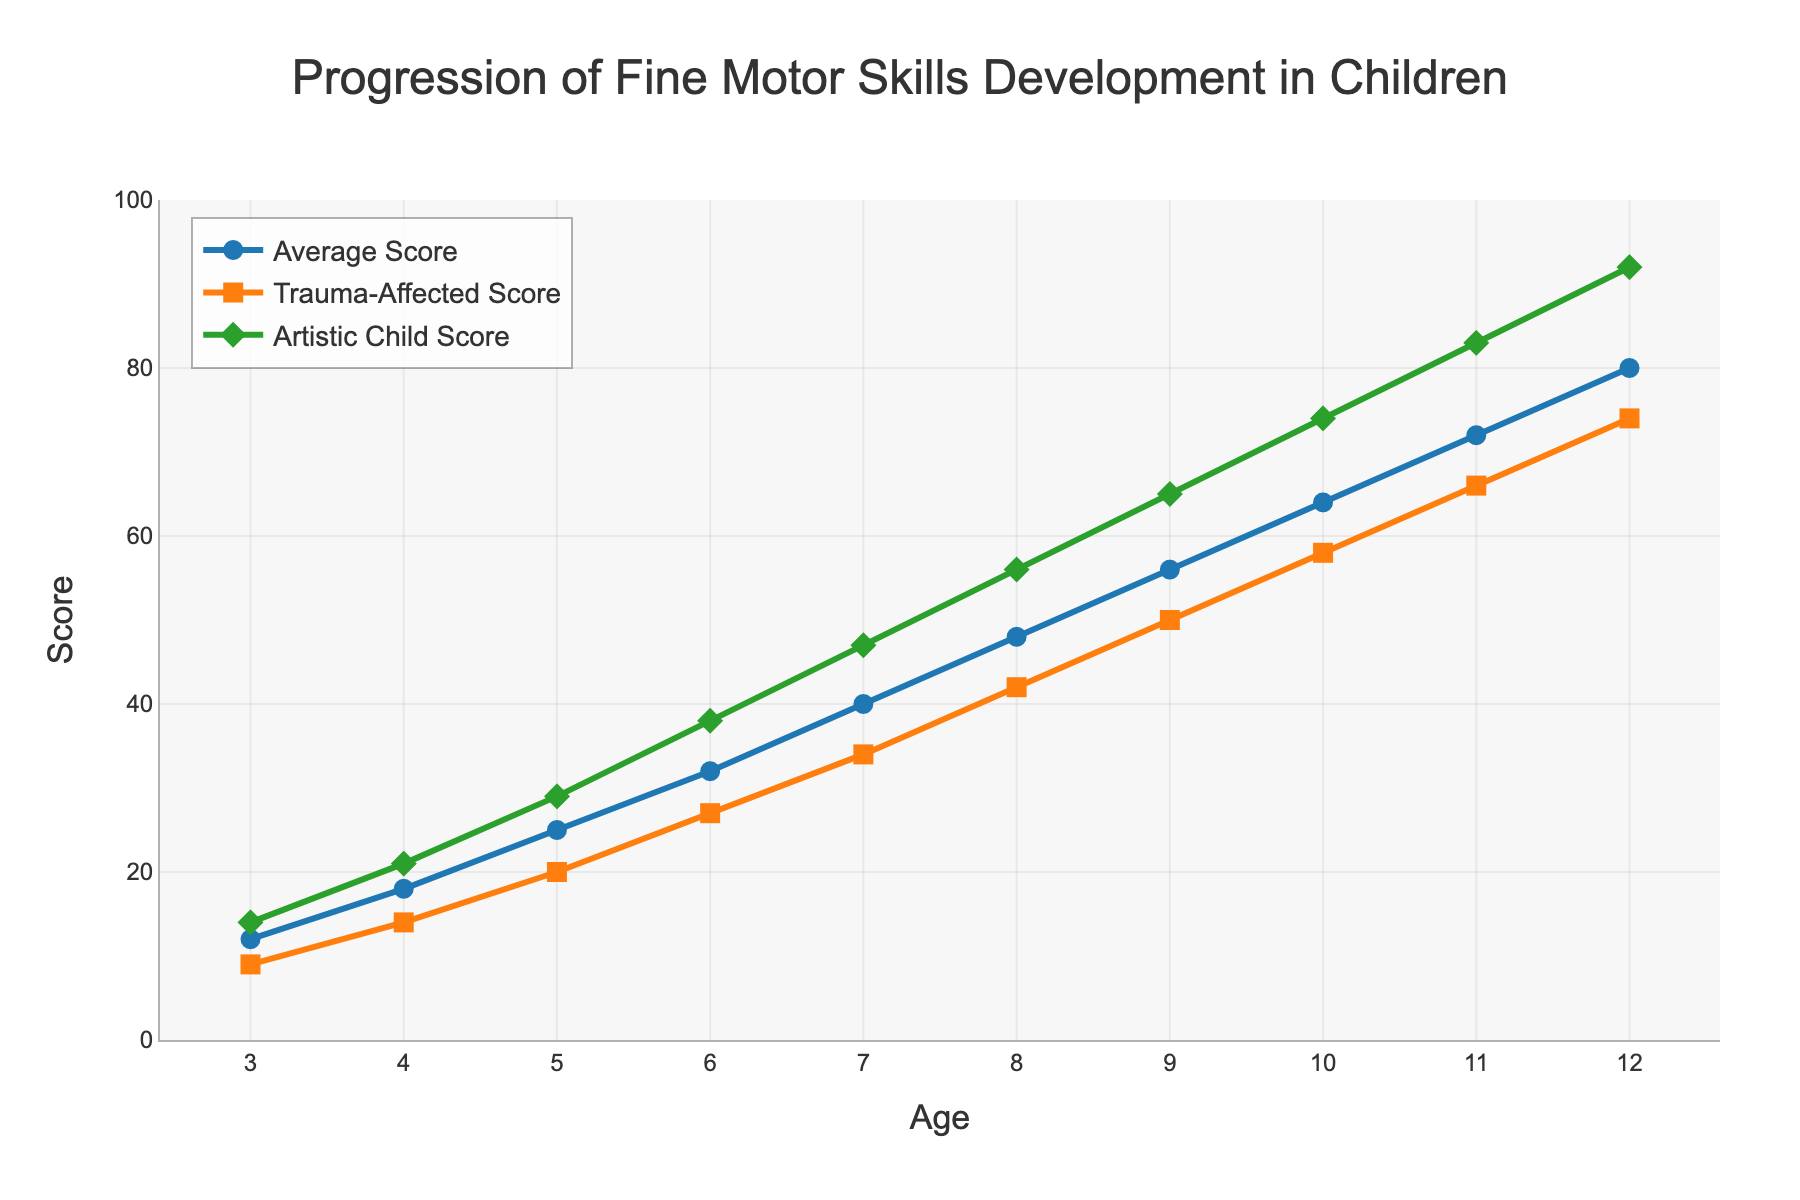What is the score difference between an average child and a trauma-affected child at age 6? Look at the score for the Average Score line and the Trauma-Affected Score line at age 6. The Average Score is 32, and the Trauma-Affected Score is 27. The difference is 32 - 27.
Answer: 5 Between which ages does the Artistic Child Score exhibit the steepest increase? Observe the slope of the Artistic Child Score line. The steepest increase is when the line ascends most sharply. From age 5 to 6, the score jumps from 29 to 38, an increase of 9 points.
Answer: 5 to 6 How many more points does an artistic child score compared to the average child at age 12? The Artistic Child Score at age 12 is 92, while the Average Score is 80. Subtract the Average Score from the Artistic Child Score: 92 - 80.
Answer: 12 Which group shows the smallest total score increase from age 3 to age 12? Calculate the total score increase for each group from age 3 to age 12. The increase for the Average Score is 80 - 12 = 68, the Trauma-Affected Score is 74 - 9 = 65, and the Artistic Child Score is 92 - 14 = 78. Compare the increases.
Answer: Trauma-Affected Between which ages does the trauma-affected group's score surpass 50 points? Follow the Trauma-Affected Score line on the plot. The score surpasses 50 points between age 8 and age 9 as it goes from 42 to 50.
Answer: Between ages 8 and 9 What is the average score of an artistic child from ages 3 to 12? Calculate the average by summing the Artistic Child Scores and dividing by the number of data points: (14 + 21 + 29 + 38 + 47 + 56 + 65 + 74 + 83 + 92) / 10. This equals 519 / 10.
Answer: 51.9 At what age does the average child's score first reach or exceed 40 points? Look at the Average Score line and find the age at which the score first reaches or exceeds 40 points. This happens at age 7.
Answer: Age 7 How much higher, on average, is the Artistic Child Score compared to the Trauma-Affected Score across all ages? Subtract the Trauma-Affected Score from the Artistic Child Score for each age, then find the average: ((14-9)+(21-14)+(29-20)+(38-27)+(47-34)+(56-42)+(65-50)+(74-58)+(83-66)+(92-74))/10. This equals (5+7+9+11+13+14+15+16+17+18)/10, which is 125/10.
Answer: 12.5 What is the visual color used to represent the trauma-affected group? Observe the color of the line and markers representing the Trauma-Affected Score on the plot. It is an orange color.
Answer: Orange 